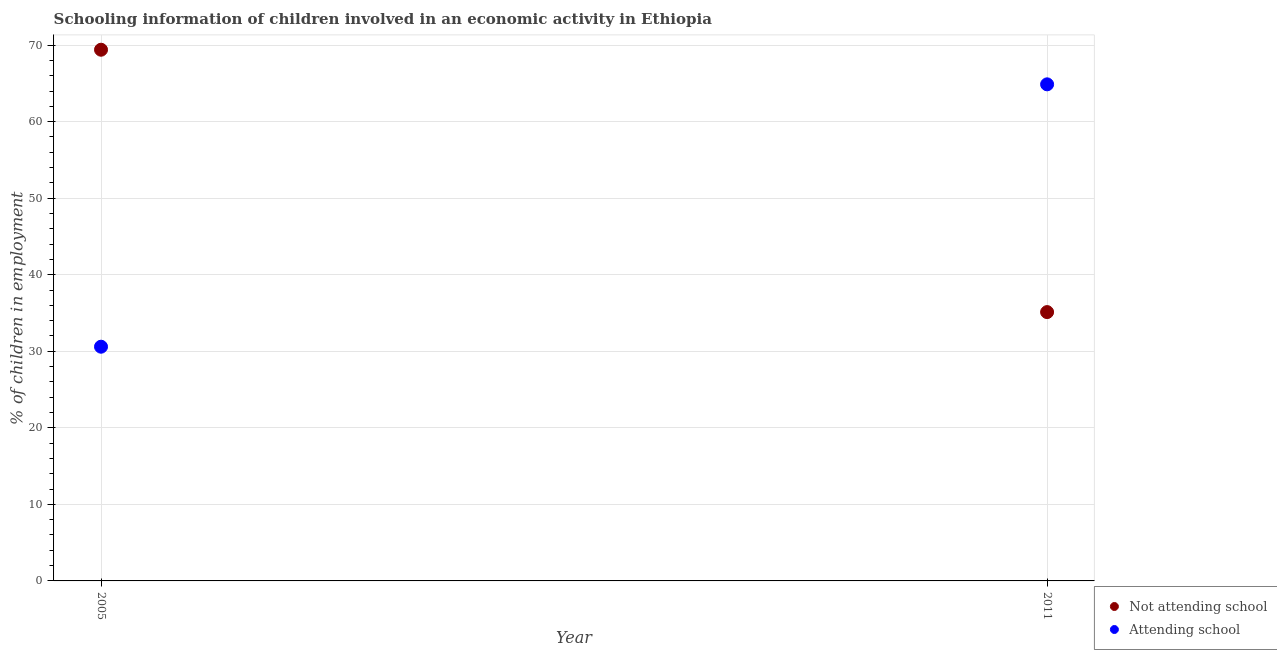Is the number of dotlines equal to the number of legend labels?
Your answer should be very brief. Yes. What is the percentage of employed children who are not attending school in 2005?
Ensure brevity in your answer.  69.4. Across all years, what is the maximum percentage of employed children who are not attending school?
Give a very brief answer. 69.4. Across all years, what is the minimum percentage of employed children who are not attending school?
Give a very brief answer. 35.12. In which year was the percentage of employed children who are not attending school maximum?
Give a very brief answer. 2005. What is the total percentage of employed children who are attending school in the graph?
Give a very brief answer. 95.48. What is the difference between the percentage of employed children who are attending school in 2005 and that in 2011?
Your answer should be very brief. -34.28. What is the difference between the percentage of employed children who are not attending school in 2011 and the percentage of employed children who are attending school in 2005?
Your response must be concise. 4.52. What is the average percentage of employed children who are attending school per year?
Your answer should be compact. 47.74. In the year 2005, what is the difference between the percentage of employed children who are attending school and percentage of employed children who are not attending school?
Keep it short and to the point. -38.8. In how many years, is the percentage of employed children who are attending school greater than 2 %?
Provide a succinct answer. 2. What is the ratio of the percentage of employed children who are attending school in 2005 to that in 2011?
Your answer should be very brief. 0.47. In how many years, is the percentage of employed children who are attending school greater than the average percentage of employed children who are attending school taken over all years?
Make the answer very short. 1. Does the percentage of employed children who are attending school monotonically increase over the years?
Provide a short and direct response. Yes. Is the percentage of employed children who are not attending school strictly less than the percentage of employed children who are attending school over the years?
Your response must be concise. No. What is the difference between two consecutive major ticks on the Y-axis?
Give a very brief answer. 10. Does the graph contain any zero values?
Keep it short and to the point. No. Does the graph contain grids?
Offer a terse response. Yes. How many legend labels are there?
Your response must be concise. 2. What is the title of the graph?
Your answer should be compact. Schooling information of children involved in an economic activity in Ethiopia. What is the label or title of the X-axis?
Provide a short and direct response. Year. What is the label or title of the Y-axis?
Your answer should be very brief. % of children in employment. What is the % of children in employment in Not attending school in 2005?
Keep it short and to the point. 69.4. What is the % of children in employment of Attending school in 2005?
Provide a short and direct response. 30.6. What is the % of children in employment in Not attending school in 2011?
Your answer should be very brief. 35.12. What is the % of children in employment in Attending school in 2011?
Provide a succinct answer. 64.88. Across all years, what is the maximum % of children in employment in Not attending school?
Keep it short and to the point. 69.4. Across all years, what is the maximum % of children in employment in Attending school?
Your response must be concise. 64.88. Across all years, what is the minimum % of children in employment of Not attending school?
Give a very brief answer. 35.12. Across all years, what is the minimum % of children in employment in Attending school?
Give a very brief answer. 30.6. What is the total % of children in employment of Not attending school in the graph?
Your answer should be very brief. 104.52. What is the total % of children in employment of Attending school in the graph?
Provide a short and direct response. 95.48. What is the difference between the % of children in employment of Not attending school in 2005 and that in 2011?
Offer a terse response. 34.28. What is the difference between the % of children in employment in Attending school in 2005 and that in 2011?
Give a very brief answer. -34.28. What is the difference between the % of children in employment in Not attending school in 2005 and the % of children in employment in Attending school in 2011?
Your answer should be compact. 4.52. What is the average % of children in employment of Not attending school per year?
Your response must be concise. 52.26. What is the average % of children in employment in Attending school per year?
Make the answer very short. 47.74. In the year 2005, what is the difference between the % of children in employment in Not attending school and % of children in employment in Attending school?
Provide a succinct answer. 38.8. In the year 2011, what is the difference between the % of children in employment in Not attending school and % of children in employment in Attending school?
Your answer should be very brief. -29.76. What is the ratio of the % of children in employment of Not attending school in 2005 to that in 2011?
Your answer should be compact. 1.98. What is the ratio of the % of children in employment of Attending school in 2005 to that in 2011?
Provide a succinct answer. 0.47. What is the difference between the highest and the second highest % of children in employment in Not attending school?
Give a very brief answer. 34.28. What is the difference between the highest and the second highest % of children in employment in Attending school?
Your answer should be compact. 34.28. What is the difference between the highest and the lowest % of children in employment of Not attending school?
Provide a short and direct response. 34.28. What is the difference between the highest and the lowest % of children in employment in Attending school?
Provide a succinct answer. 34.28. 